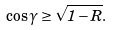<formula> <loc_0><loc_0><loc_500><loc_500>\cos \gamma \geq \sqrt { 1 - R } .</formula> 